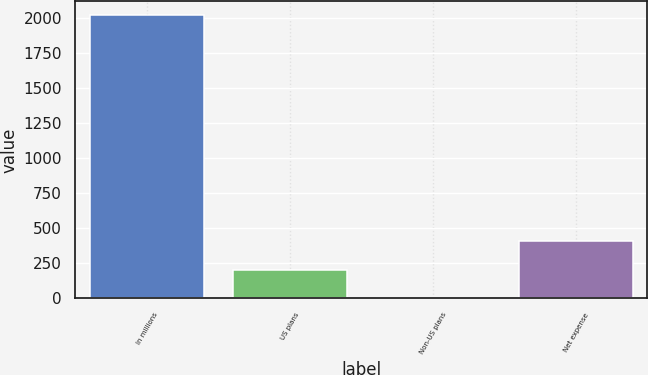Convert chart. <chart><loc_0><loc_0><loc_500><loc_500><bar_chart><fcel>In millions<fcel>US plans<fcel>Non-US plans<fcel>Net expense<nl><fcel>2020<fcel>205.6<fcel>4<fcel>407.2<nl></chart> 